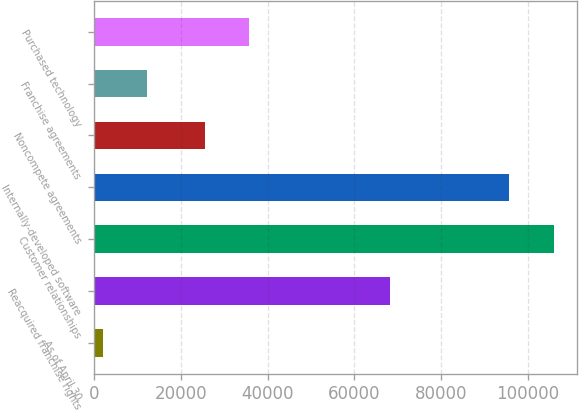Convert chart to OTSL. <chart><loc_0><loc_0><loc_500><loc_500><bar_chart><fcel>As of April 30<fcel>Reacquired franchise rights<fcel>Customer relationships<fcel>Internally-developed software<fcel>Noncompete agreements<fcel>Franchise agreements<fcel>Purchased technology<nl><fcel>2016<fcel>68284<fcel>105974<fcel>95768<fcel>25572<fcel>12221.6<fcel>35777.6<nl></chart> 